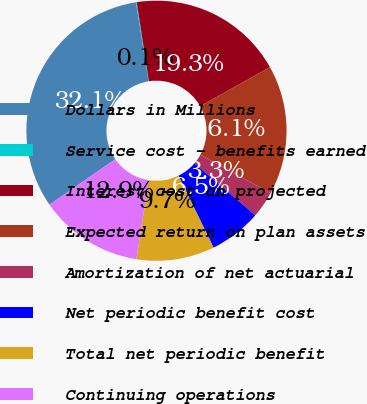Convert chart to OTSL. <chart><loc_0><loc_0><loc_500><loc_500><pie_chart><fcel>Dollars in Millions<fcel>Service cost - benefits earned<fcel>Interest cost on projected<fcel>Expected return on plan assets<fcel>Amortization of net actuarial<fcel>Net periodic benefit cost<fcel>Total net periodic benefit<fcel>Continuing operations<nl><fcel>32.11%<fcel>0.1%<fcel>19.3%<fcel>16.1%<fcel>3.3%<fcel>6.5%<fcel>9.7%<fcel>12.9%<nl></chart> 